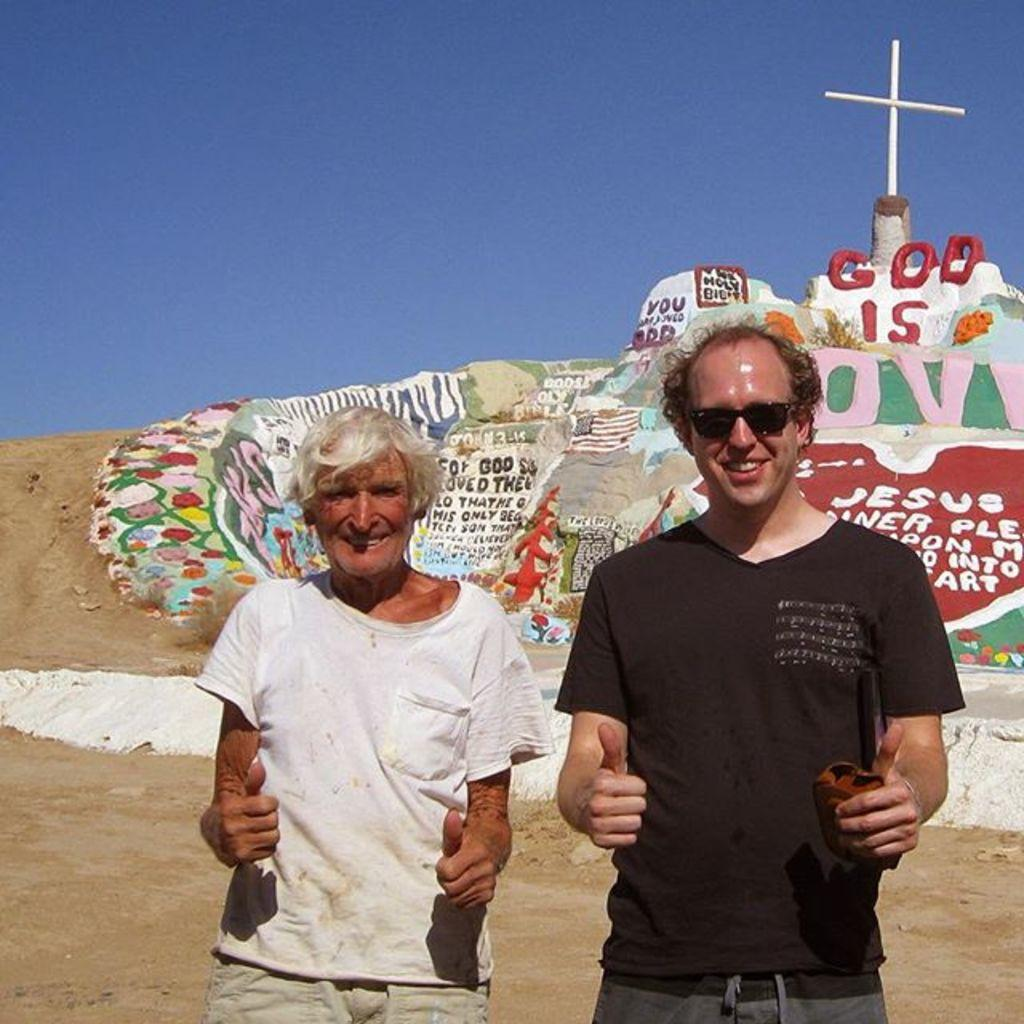How many people are in the image? There are two people standing in the image. What is the facial expression of the people in the image? The people are smiling. What can be seen in the background of the image? There is ground, a cross, paintings, text, and the sky visible in the background of the image. What type of island can be seen in the background of the image? There is no island present in the image; it features a cross, paintings, text, and the sky in the background. What song is being sung by the people in the image? There is no indication in the image that the people are singing a song, so it cannot be determined from the picture. 